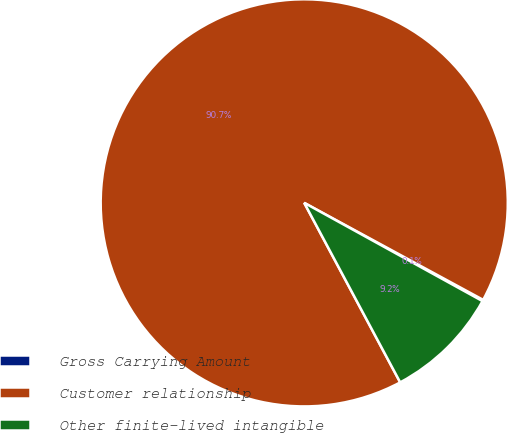Convert chart to OTSL. <chart><loc_0><loc_0><loc_500><loc_500><pie_chart><fcel>Gross Carrying Amount<fcel>Customer relationship<fcel>Other finite-lived intangible<nl><fcel>0.11%<fcel>90.71%<fcel>9.17%<nl></chart> 